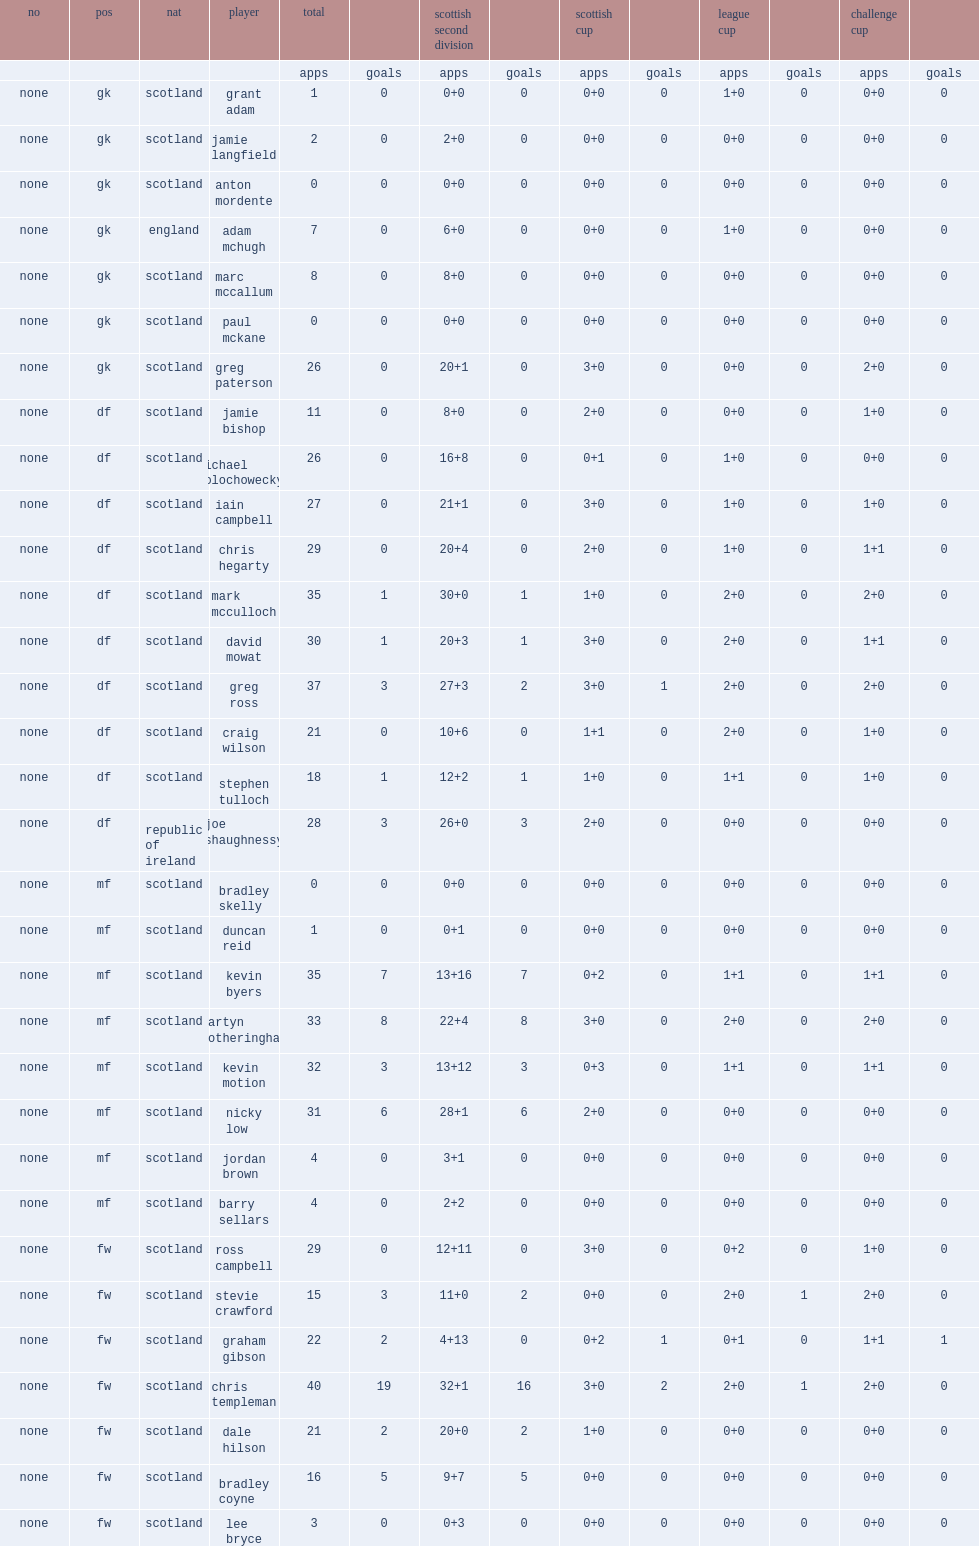List the matches that forfar athletic competed in. Challenge cup league cup scottish cup. 